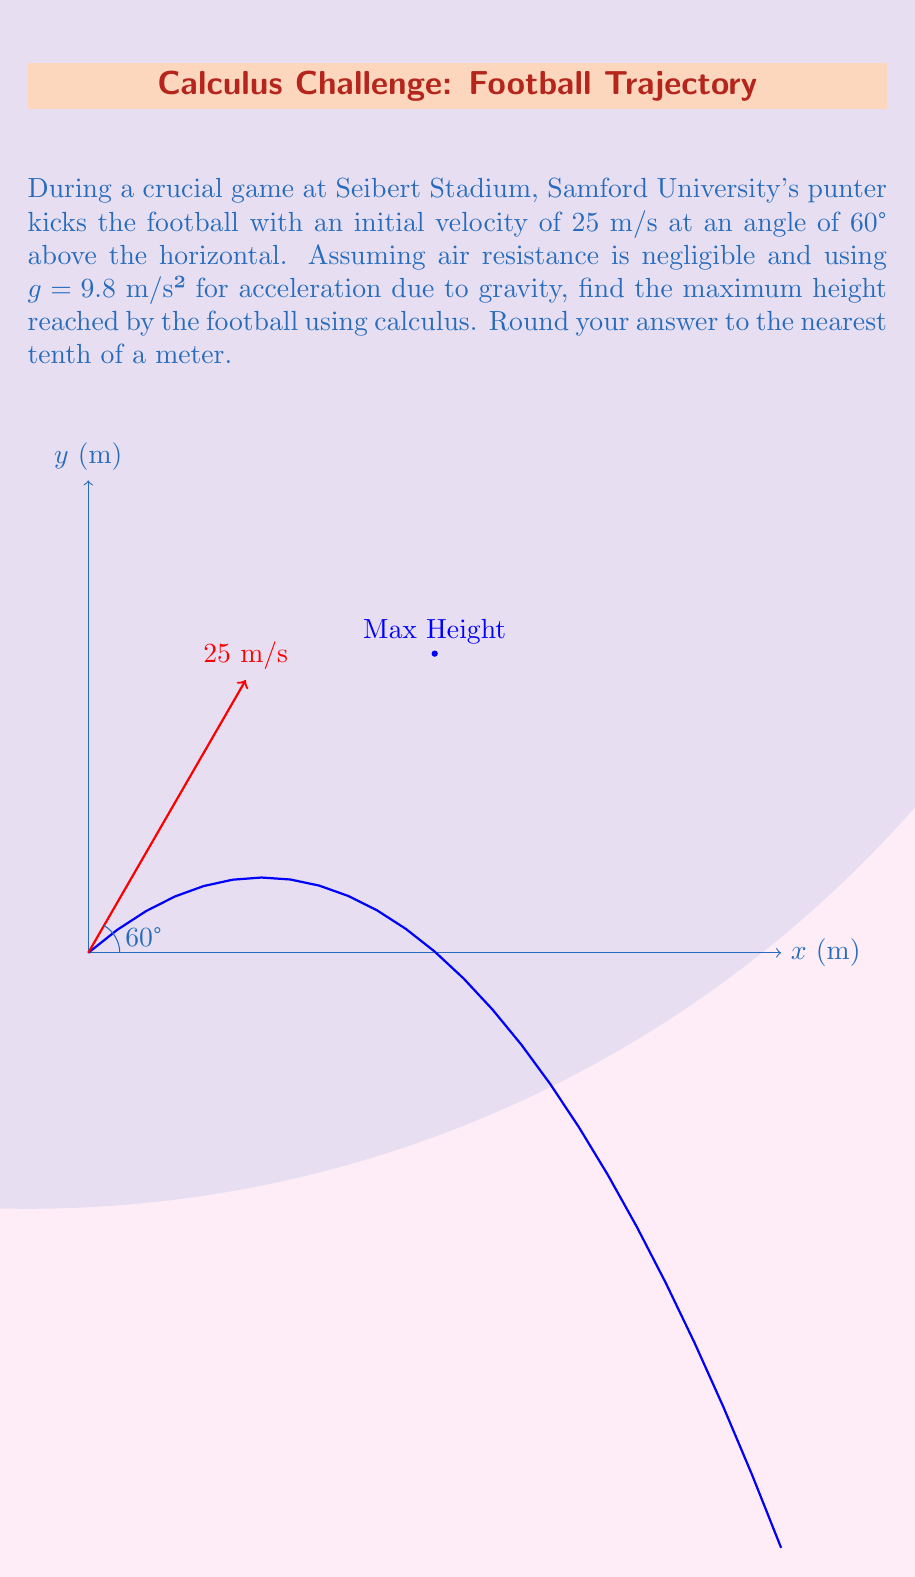What is the answer to this math problem? Let's approach this step-by-step using calculus:

1) First, we need to set up the equations of motion. The position of the football at time t is given by:

   $$x(t) = v_0 \cos(\theta) t$$
   $$y(t) = v_0 \sin(\theta) t - \frac{1}{2}gt^2$$

   where $v_0 = 25$ m/s, $\theta = 60°$, and $g = 9.8$ m/s².

2) Substituting the values:

   $$y(t) = 25 \sin(60°) t - \frac{1}{2}(9.8)t^2$$
   $$y(t) = 21.65t - 4.9t^2$$

3) To find the maximum height, we need to find where the vertical velocity ($\frac{dy}{dt}$) is zero:

   $$\frac{dy}{dt} = 21.65 - 9.8t$$

4) Set this equal to zero and solve for t:

   $$21.65 - 9.8t = 0$$
   $$t = \frac{21.65}{9.8} = 2.21 \text{ seconds}$$

5) This is the time when the football reaches its maximum height. To find the height, we substitute this time back into our original y(t) equation:

   $$y(2.21) = 21.65(2.21) - 4.9(2.21)^2$$
   $$y(2.21) = 47.85 - 23.93 = 23.92 \text{ meters}$$

6) Rounding to the nearest tenth:

   Maximum height ≈ 23.9 meters
Answer: 23.9 meters 